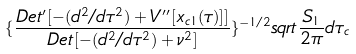<formula> <loc_0><loc_0><loc_500><loc_500>\{ \frac { D e t ^ { \prime } [ - ( d ^ { 2 } / d \tau ^ { 2 } ) + V ^ { \prime \prime } [ x _ { c 1 } ( \tau ) ] ] } { D e t [ - ( d ^ { 2 } / d \tau ^ { 2 } ) + \nu ^ { 2 } ] } \} ^ { - 1 / 2 } s q r t \frac { S _ { 1 } } { 2 \pi } d \tau _ { c }</formula> 